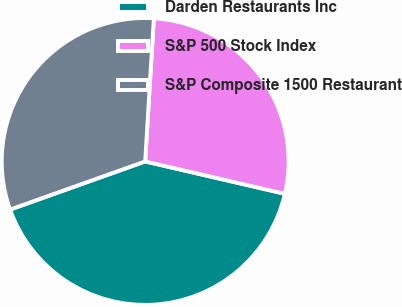<chart> <loc_0><loc_0><loc_500><loc_500><pie_chart><fcel>Darden Restaurants Inc<fcel>S&P 500 Stock Index<fcel>S&P Composite 1500 Restaurant<nl><fcel>40.93%<fcel>27.66%<fcel>31.41%<nl></chart> 